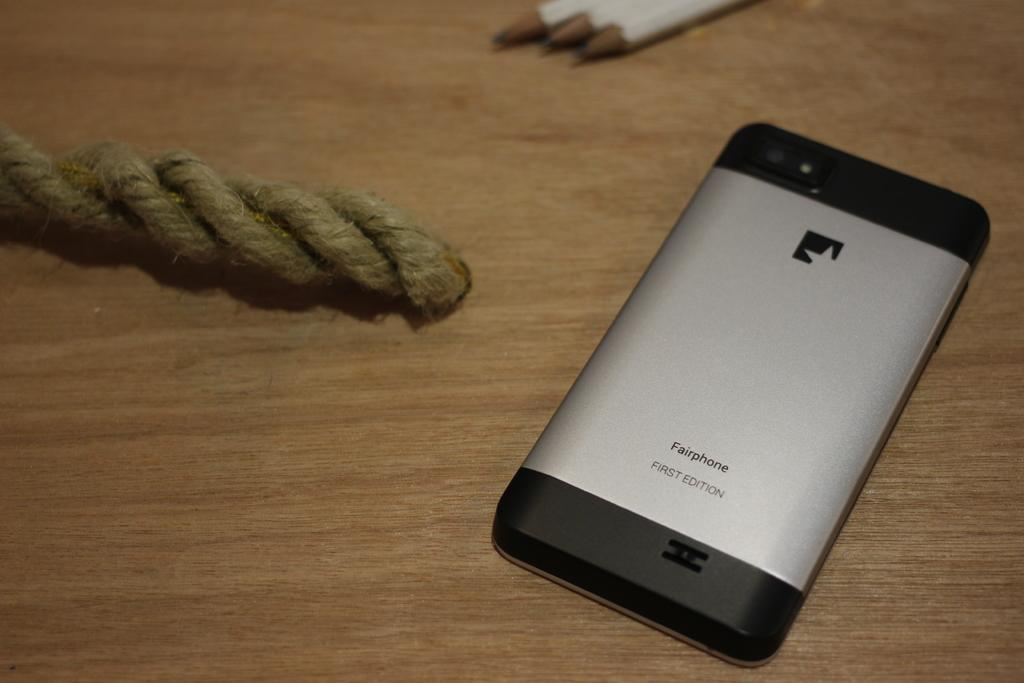What object is on the table in the image? There is a phone on the table in the image. What can be seen at the top of the image? There are three pencils at the top of the image. Where is the stamp located in the image? There is no stamp present in the image. What type of muscle can be seen in the image? There are no muscles visible in the image. 